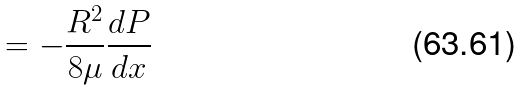Convert formula to latex. <formula><loc_0><loc_0><loc_500><loc_500>= - \frac { R ^ { 2 } } { 8 \mu } \frac { d P } { d x }</formula> 